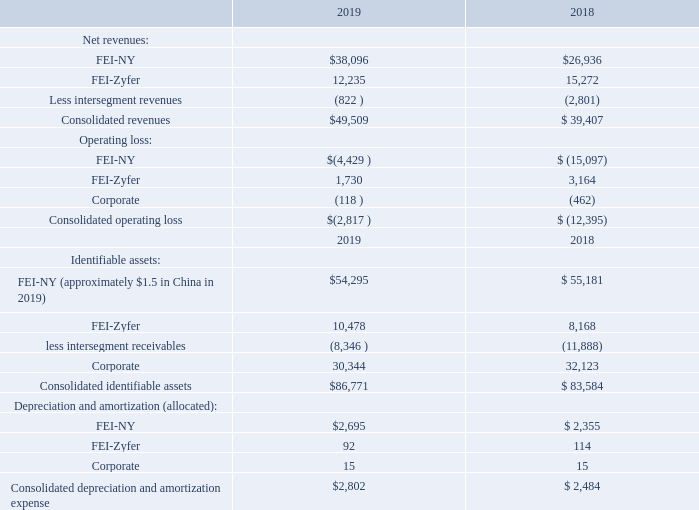14. Segment Information
The Company operates under two reportable segments based on the geographic locations of its subsidiaries:
(1)  FEI-NY – operates out of New York and its operations consist principally of precision time and frequency control products used in three principal markets- communication satellites (both commercial and U.S. Government-funded); terrestrial cellular telephone or other ground-based telecommunication stations; and other components and systems for the U.S. military.
The FEI-NY segment also includes the operations of the Company’s wholly-owned subsidiaries, FEI-Elcom and FEI-Asia. FEI- Asia functions as a manufacturing facility for the FEI-NY segment with historically minimal sales to outside customers. FEI- Elcom, in addition to its own product line, provides design and technical support for the FEI-NY segment’s satellite business.
(2)  FEI-Zyfer – operates out of California and its products incorporate Global Positioning System (GPS) technologies into systems and subsystems for secure communications, both government and commercial, and other locator applications. This segment also provides sales and support for the Company’s wireline telecommunications family of products, including US5G, which are sold in the U. S. market.
The Company measures segment performance based on total revenues and profits generated by each geographic location rather than on the specific types of customers or end-users. Consequently, the Company determined that the segments indicated above most appropriately reflect the way the Company’s management views the business.
The accounting policies of the two segments are the same as those described in the “Summary of Significant Accounting Policies.” The Company evaluates the performance of its segments and allocates resources to them based on operating profit which is defined as income before investment income, interest expense and taxes. All acquired assets, including intangible assets, are included in the assets of both reporting segments.
The table below presents information about reported segments for each of the years ended April 30, 2019 and 2018, respectively, with reconciliation of segment amounts to consolidated amounts as reported in the statement of operations or the balance sheet for each of the years (in thousands):
What are the net revenues from FEI-NY in 2019 and 2018 respectively?
Answer scale should be: thousand. $38,096, $26,936. What are the net revenues from FEI-Zyfer in 2019 and 2018 respectively?
Answer scale should be: thousand. 12,235, 15,272. How does the company measure segment performance? Based on total revenues and profits generated by each geographic location. What is the change in net revenues from FEI-NY between 2018 and 2019?
Answer scale should be: thousand. 38,096-26,936
Answer: 11160. What is the average net revenue from FEI-Zyfer in 2018 and 2019?
Answer scale should be: thousand. (12,235+15,272)/2
Answer: 13753.5. In 2019, what is the percentage constitution of the revenue from FEI-NY among the total consolidated revenues?
Answer scale should be: percent. 38,096/49,509
Answer: 76.95. 